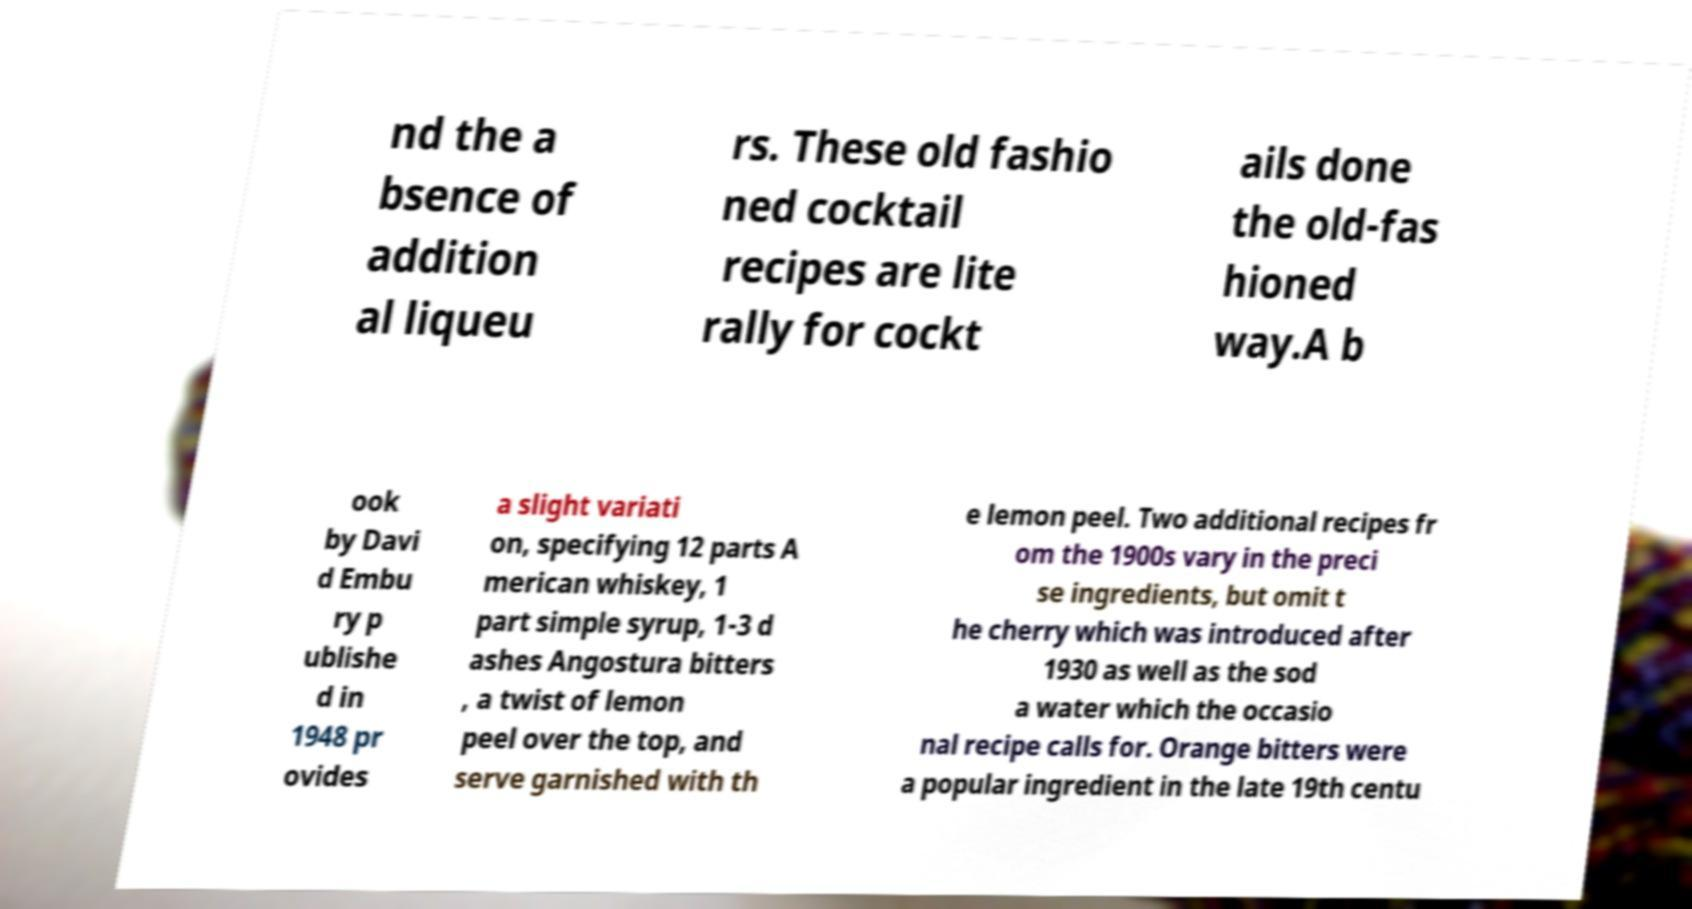Please read and relay the text visible in this image. What does it say? nd the a bsence of addition al liqueu rs. These old fashio ned cocktail recipes are lite rally for cockt ails done the old-fas hioned way.A b ook by Davi d Embu ry p ublishe d in 1948 pr ovides a slight variati on, specifying 12 parts A merican whiskey, 1 part simple syrup, 1-3 d ashes Angostura bitters , a twist of lemon peel over the top, and serve garnished with th e lemon peel. Two additional recipes fr om the 1900s vary in the preci se ingredients, but omit t he cherry which was introduced after 1930 as well as the sod a water which the occasio nal recipe calls for. Orange bitters were a popular ingredient in the late 19th centu 